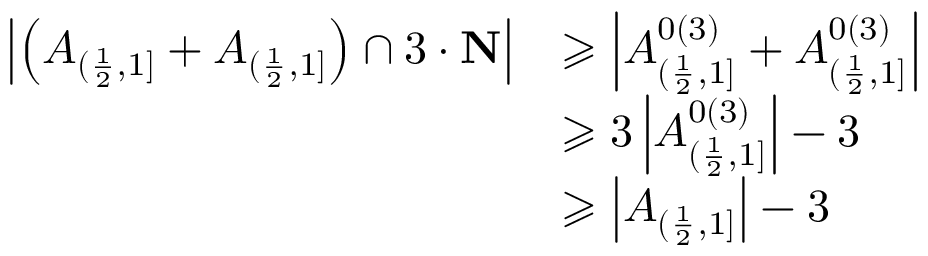Convert formula to latex. <formula><loc_0><loc_0><loc_500><loc_500>\begin{array} { r l } { \left | \left ( A _ { ( \frac { 1 } { 2 } , 1 ] } + A _ { ( \frac { 1 } { 2 } , 1 ] } \right ) \cap 3 \cdot N \right | } & { \geqslant \left | A _ { ( \frac { 1 } { 2 } , 1 ] } ^ { 0 ( 3 ) } + A _ { ( \frac { 1 } { 2 } , 1 ] } ^ { 0 ( 3 ) } \right | } \\ & { \geqslant 3 \left | A _ { ( \frac { 1 } { 2 } , 1 ] } ^ { 0 ( 3 ) } \right | - 3 } \\ & { \geqslant \left | A _ { ( \frac { 1 } { 2 } , 1 ] } \right | - 3 } \end{array}</formula> 